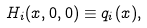<formula> <loc_0><loc_0><loc_500><loc_500>H _ { i } ( x , 0 , 0 ) \equiv q _ { i } ( x ) ,</formula> 